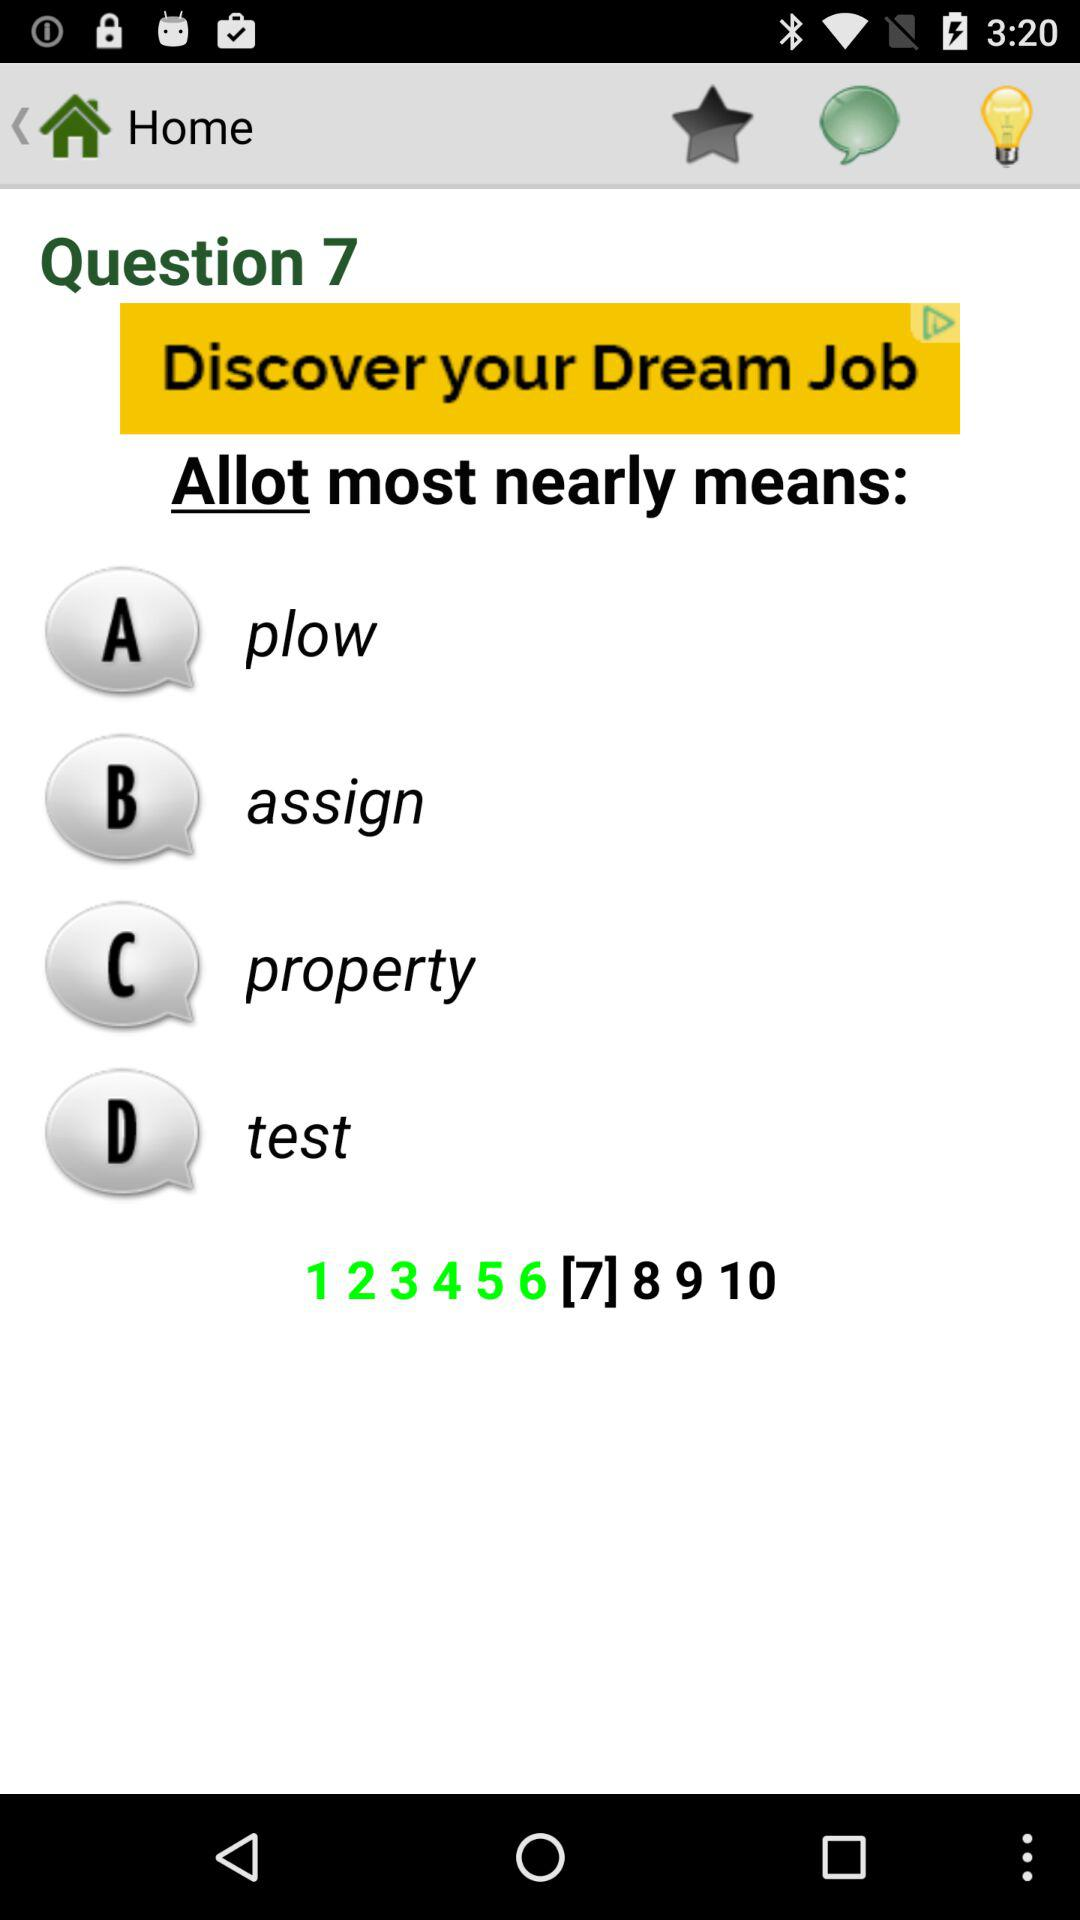How many questions in total are there? There are 10 questions in total. 